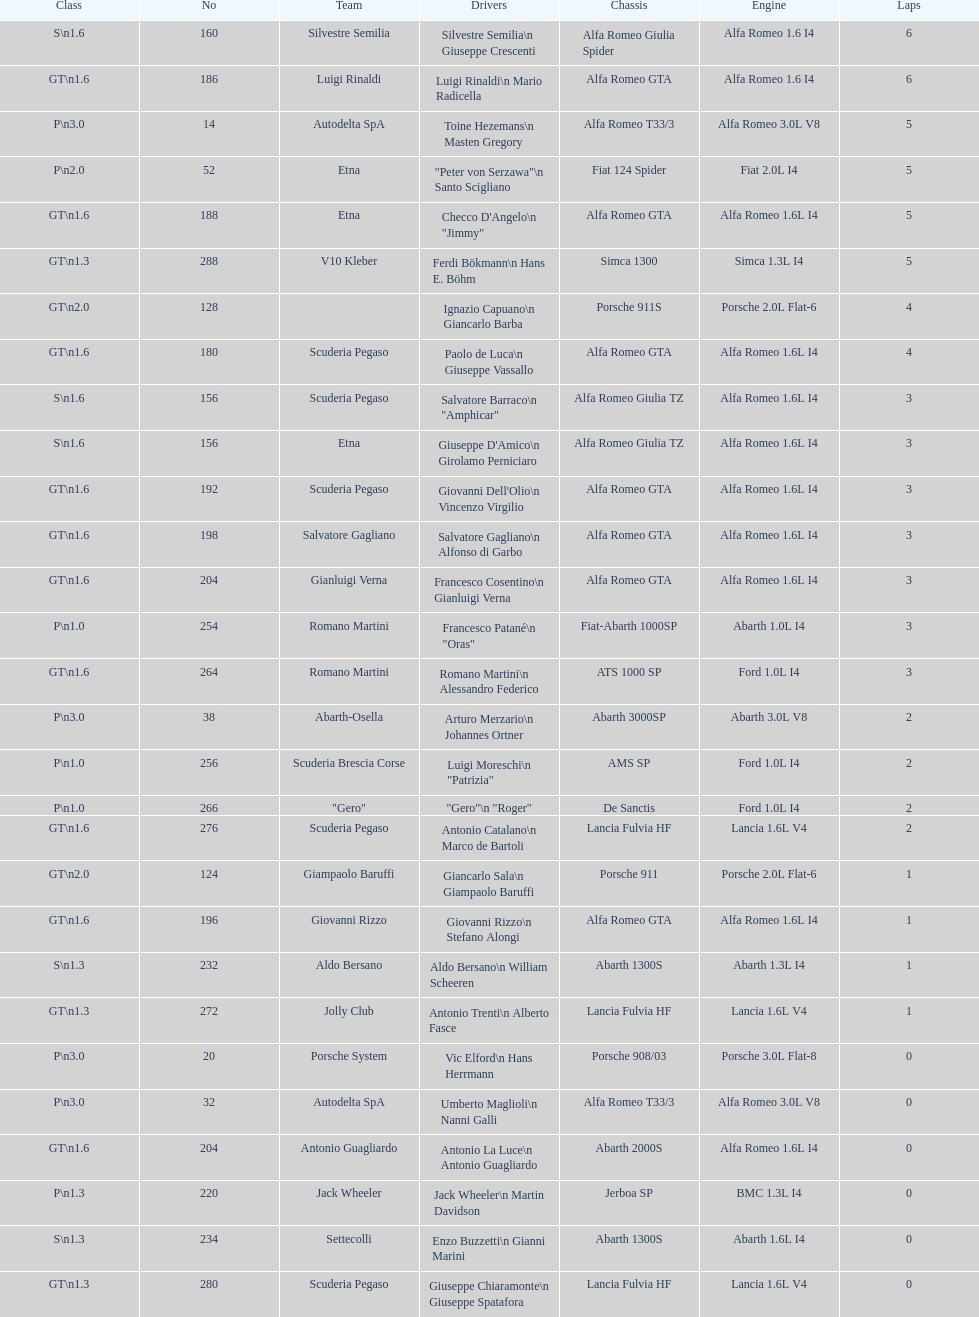6? GT 1.6. 